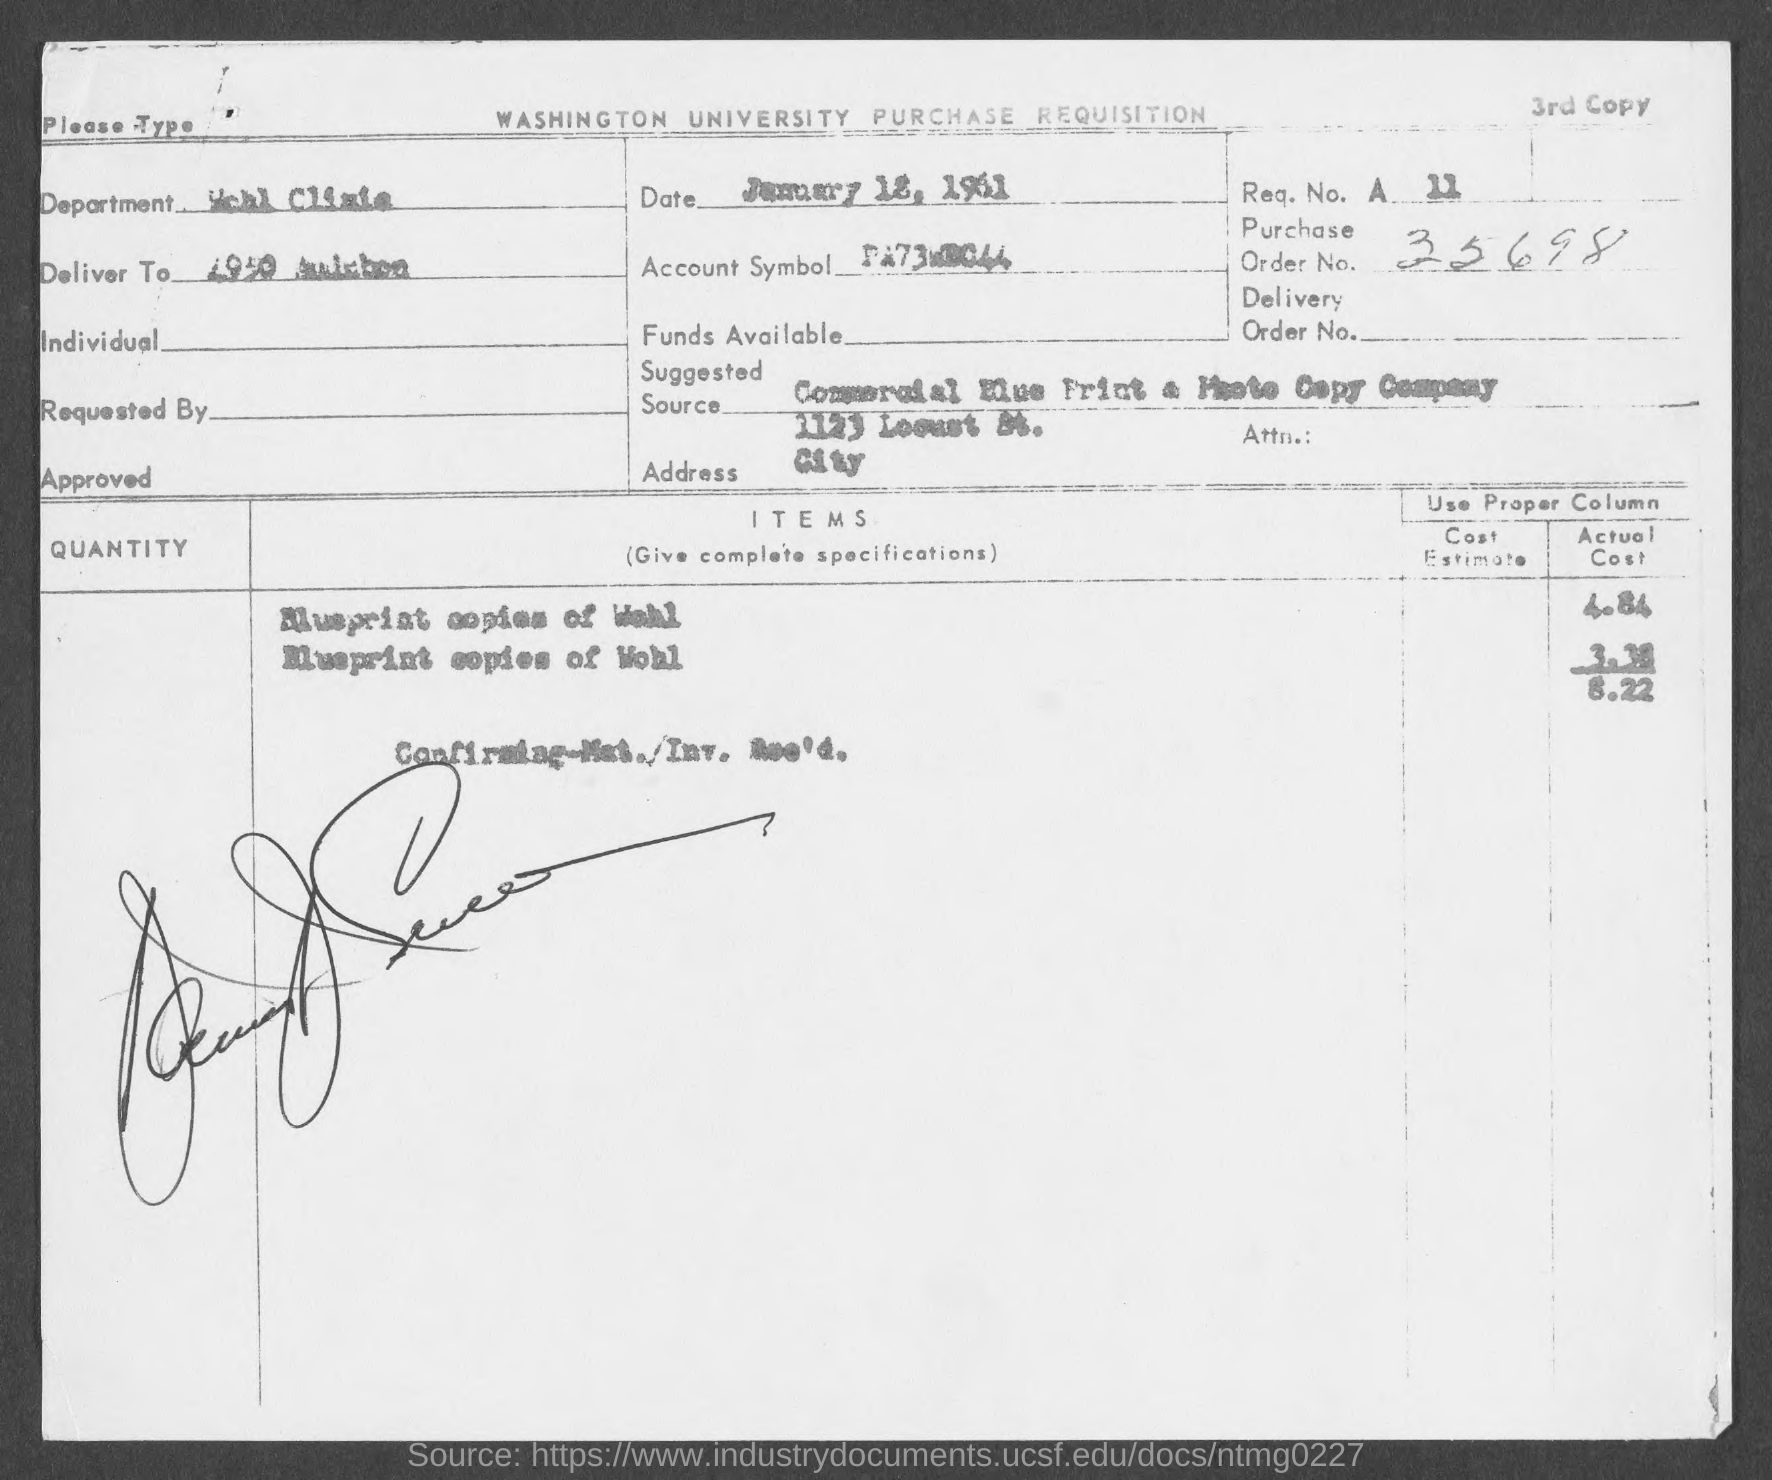Indicate a few pertinent items in this graphic. What is the purchase order number? 35698... 